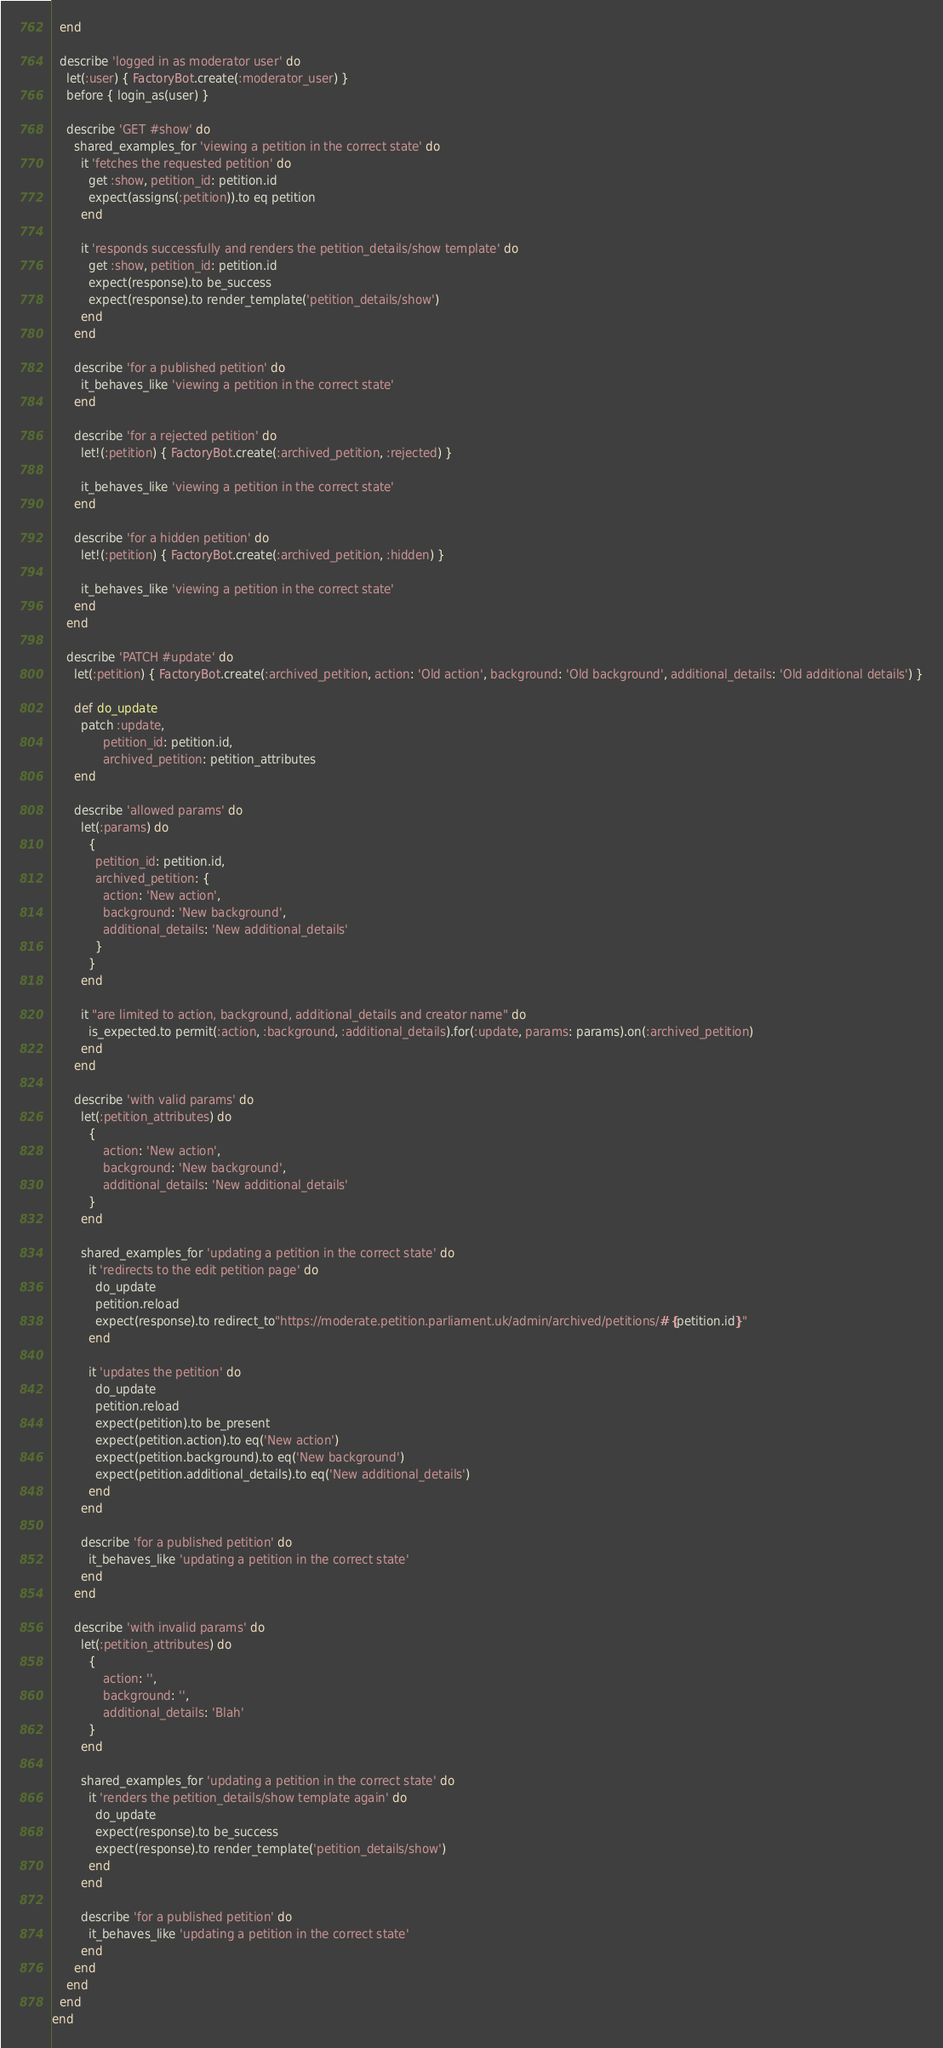<code> <loc_0><loc_0><loc_500><loc_500><_Ruby_>  end

  describe 'logged in as moderator user' do
    let(:user) { FactoryBot.create(:moderator_user) }
    before { login_as(user) }

    describe 'GET #show' do
      shared_examples_for 'viewing a petition in the correct state' do
        it 'fetches the requested petition' do
          get :show, petition_id: petition.id
          expect(assigns(:petition)).to eq petition
        end

        it 'responds successfully and renders the petition_details/show template' do
          get :show, petition_id: petition.id
          expect(response).to be_success
          expect(response).to render_template('petition_details/show')
        end
      end

      describe 'for a published petition' do
        it_behaves_like 'viewing a petition in the correct state'
      end

      describe 'for a rejected petition' do
        let!(:petition) { FactoryBot.create(:archived_petition, :rejected) }

        it_behaves_like 'viewing a petition in the correct state'
      end

      describe 'for a hidden petition' do
        let!(:petition) { FactoryBot.create(:archived_petition, :hidden) }

        it_behaves_like 'viewing a petition in the correct state'
      end
    end

    describe 'PATCH #update' do
      let(:petition) { FactoryBot.create(:archived_petition, action: 'Old action', background: 'Old background', additional_details: 'Old additional details') }

      def do_update
        patch :update,
              petition_id: petition.id,
              archived_petition: petition_attributes
      end

      describe 'allowed params' do
        let(:params) do
          {
            petition_id: petition.id,
            archived_petition: {
              action: 'New action',
              background: 'New background',
              additional_details: 'New additional_details'
            }
          }
        end

        it "are limited to action, background, additional_details and creator name" do
          is_expected.to permit(:action, :background, :additional_details).for(:update, params: params).on(:archived_petition)
        end
      end

      describe 'with valid params' do
        let(:petition_attributes) do
          {
              action: 'New action',
              background: 'New background',
              additional_details: 'New additional_details'
          }
        end

        shared_examples_for 'updating a petition in the correct state' do
          it 'redirects to the edit petition page' do
            do_update
            petition.reload
            expect(response).to redirect_to"https://moderate.petition.parliament.uk/admin/archived/petitions/#{petition.id}"
          end

          it 'updates the petition' do
            do_update
            petition.reload
            expect(petition).to be_present
            expect(petition.action).to eq('New action')
            expect(petition.background).to eq('New background')
            expect(petition.additional_details).to eq('New additional_details')
          end
        end

        describe 'for a published petition' do
          it_behaves_like 'updating a petition in the correct state'
        end
      end

      describe 'with invalid params' do
        let(:petition_attributes) do
          {
              action: '',
              background: '',
              additional_details: 'Blah'
          }
        end

        shared_examples_for 'updating a petition in the correct state' do
          it 'renders the petition_details/show template again' do
            do_update
            expect(response).to be_success
            expect(response).to render_template('petition_details/show')
          end
        end

        describe 'for a published petition' do
          it_behaves_like 'updating a petition in the correct state'
        end
      end
    end
  end
end
</code> 